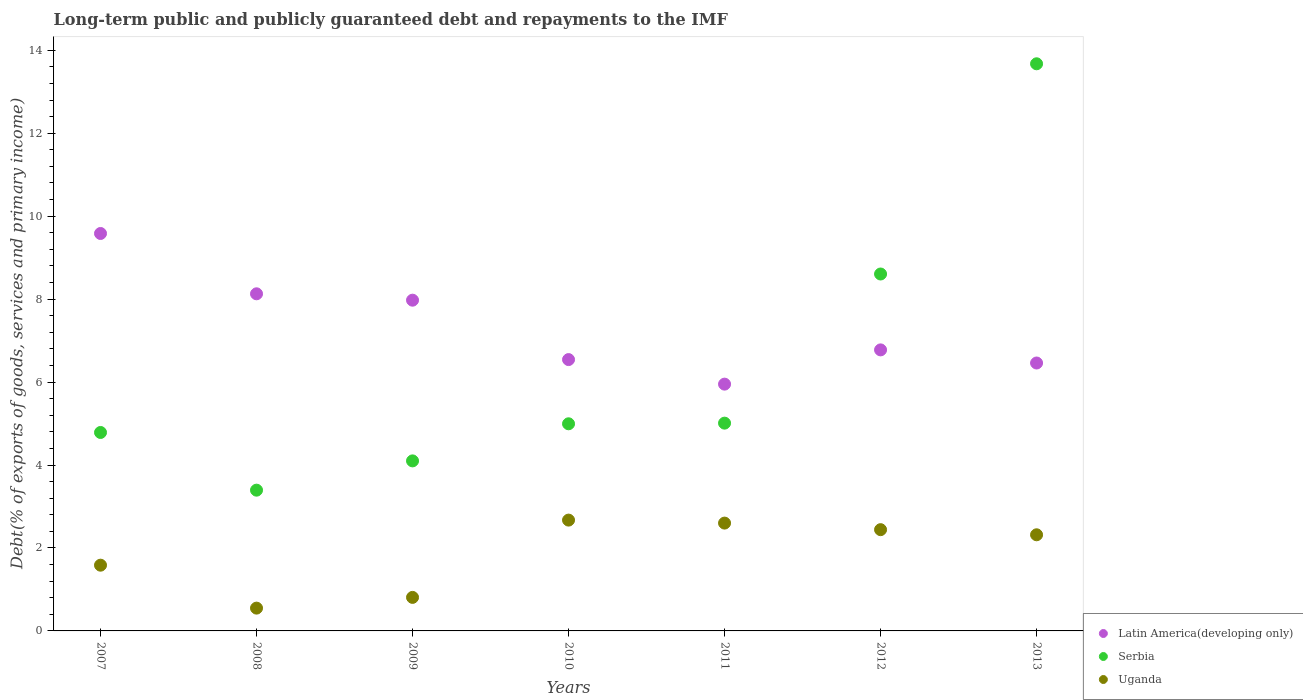How many different coloured dotlines are there?
Ensure brevity in your answer.  3. What is the debt and repayments in Latin America(developing only) in 2012?
Provide a succinct answer. 6.78. Across all years, what is the maximum debt and repayments in Serbia?
Offer a very short reply. 13.67. Across all years, what is the minimum debt and repayments in Serbia?
Make the answer very short. 3.39. What is the total debt and repayments in Serbia in the graph?
Make the answer very short. 44.56. What is the difference between the debt and repayments in Latin America(developing only) in 2010 and that in 2012?
Your answer should be very brief. -0.23. What is the difference between the debt and repayments in Uganda in 2012 and the debt and repayments in Serbia in 2008?
Ensure brevity in your answer.  -0.95. What is the average debt and repayments in Uganda per year?
Provide a short and direct response. 1.85. In the year 2008, what is the difference between the debt and repayments in Serbia and debt and repayments in Latin America(developing only)?
Your answer should be compact. -4.73. What is the ratio of the debt and repayments in Serbia in 2008 to that in 2013?
Provide a short and direct response. 0.25. What is the difference between the highest and the second highest debt and repayments in Serbia?
Your answer should be compact. 5.07. What is the difference between the highest and the lowest debt and repayments in Uganda?
Make the answer very short. 2.12. Is it the case that in every year, the sum of the debt and repayments in Serbia and debt and repayments in Latin America(developing only)  is greater than the debt and repayments in Uganda?
Offer a very short reply. Yes. How many dotlines are there?
Offer a very short reply. 3. How are the legend labels stacked?
Offer a terse response. Vertical. What is the title of the graph?
Keep it short and to the point. Long-term public and publicly guaranteed debt and repayments to the IMF. Does "Kiribati" appear as one of the legend labels in the graph?
Provide a succinct answer. No. What is the label or title of the Y-axis?
Provide a short and direct response. Debt(% of exports of goods, services and primary income). What is the Debt(% of exports of goods, services and primary income) in Latin America(developing only) in 2007?
Give a very brief answer. 9.58. What is the Debt(% of exports of goods, services and primary income) in Serbia in 2007?
Offer a very short reply. 4.78. What is the Debt(% of exports of goods, services and primary income) in Uganda in 2007?
Your answer should be very brief. 1.58. What is the Debt(% of exports of goods, services and primary income) in Latin America(developing only) in 2008?
Offer a very short reply. 8.13. What is the Debt(% of exports of goods, services and primary income) of Serbia in 2008?
Make the answer very short. 3.39. What is the Debt(% of exports of goods, services and primary income) of Uganda in 2008?
Offer a terse response. 0.55. What is the Debt(% of exports of goods, services and primary income) of Latin America(developing only) in 2009?
Make the answer very short. 7.97. What is the Debt(% of exports of goods, services and primary income) of Serbia in 2009?
Your response must be concise. 4.1. What is the Debt(% of exports of goods, services and primary income) in Uganda in 2009?
Provide a succinct answer. 0.81. What is the Debt(% of exports of goods, services and primary income) in Latin America(developing only) in 2010?
Offer a very short reply. 6.54. What is the Debt(% of exports of goods, services and primary income) of Serbia in 2010?
Keep it short and to the point. 4.99. What is the Debt(% of exports of goods, services and primary income) of Uganda in 2010?
Give a very brief answer. 2.67. What is the Debt(% of exports of goods, services and primary income) of Latin America(developing only) in 2011?
Offer a very short reply. 5.95. What is the Debt(% of exports of goods, services and primary income) of Serbia in 2011?
Provide a succinct answer. 5.01. What is the Debt(% of exports of goods, services and primary income) in Uganda in 2011?
Give a very brief answer. 2.6. What is the Debt(% of exports of goods, services and primary income) in Latin America(developing only) in 2012?
Make the answer very short. 6.78. What is the Debt(% of exports of goods, services and primary income) of Serbia in 2012?
Your answer should be compact. 8.6. What is the Debt(% of exports of goods, services and primary income) of Uganda in 2012?
Offer a terse response. 2.44. What is the Debt(% of exports of goods, services and primary income) of Latin America(developing only) in 2013?
Your answer should be very brief. 6.46. What is the Debt(% of exports of goods, services and primary income) of Serbia in 2013?
Your answer should be compact. 13.67. What is the Debt(% of exports of goods, services and primary income) in Uganda in 2013?
Your answer should be compact. 2.32. Across all years, what is the maximum Debt(% of exports of goods, services and primary income) of Latin America(developing only)?
Provide a succinct answer. 9.58. Across all years, what is the maximum Debt(% of exports of goods, services and primary income) of Serbia?
Your response must be concise. 13.67. Across all years, what is the maximum Debt(% of exports of goods, services and primary income) of Uganda?
Make the answer very short. 2.67. Across all years, what is the minimum Debt(% of exports of goods, services and primary income) of Latin America(developing only)?
Your answer should be compact. 5.95. Across all years, what is the minimum Debt(% of exports of goods, services and primary income) of Serbia?
Ensure brevity in your answer.  3.39. Across all years, what is the minimum Debt(% of exports of goods, services and primary income) of Uganda?
Your answer should be very brief. 0.55. What is the total Debt(% of exports of goods, services and primary income) in Latin America(developing only) in the graph?
Make the answer very short. 51.41. What is the total Debt(% of exports of goods, services and primary income) in Serbia in the graph?
Your answer should be very brief. 44.56. What is the total Debt(% of exports of goods, services and primary income) of Uganda in the graph?
Your answer should be compact. 12.97. What is the difference between the Debt(% of exports of goods, services and primary income) in Latin America(developing only) in 2007 and that in 2008?
Your answer should be compact. 1.45. What is the difference between the Debt(% of exports of goods, services and primary income) of Serbia in 2007 and that in 2008?
Offer a terse response. 1.39. What is the difference between the Debt(% of exports of goods, services and primary income) in Uganda in 2007 and that in 2008?
Give a very brief answer. 1.04. What is the difference between the Debt(% of exports of goods, services and primary income) in Latin America(developing only) in 2007 and that in 2009?
Make the answer very short. 1.61. What is the difference between the Debt(% of exports of goods, services and primary income) of Serbia in 2007 and that in 2009?
Keep it short and to the point. 0.69. What is the difference between the Debt(% of exports of goods, services and primary income) in Uganda in 2007 and that in 2009?
Your response must be concise. 0.78. What is the difference between the Debt(% of exports of goods, services and primary income) of Latin America(developing only) in 2007 and that in 2010?
Make the answer very short. 3.04. What is the difference between the Debt(% of exports of goods, services and primary income) of Serbia in 2007 and that in 2010?
Provide a short and direct response. -0.21. What is the difference between the Debt(% of exports of goods, services and primary income) of Uganda in 2007 and that in 2010?
Offer a terse response. -1.09. What is the difference between the Debt(% of exports of goods, services and primary income) in Latin America(developing only) in 2007 and that in 2011?
Provide a succinct answer. 3.63. What is the difference between the Debt(% of exports of goods, services and primary income) in Serbia in 2007 and that in 2011?
Make the answer very short. -0.23. What is the difference between the Debt(% of exports of goods, services and primary income) of Uganda in 2007 and that in 2011?
Offer a very short reply. -1.01. What is the difference between the Debt(% of exports of goods, services and primary income) in Latin America(developing only) in 2007 and that in 2012?
Give a very brief answer. 2.81. What is the difference between the Debt(% of exports of goods, services and primary income) of Serbia in 2007 and that in 2012?
Your response must be concise. -3.82. What is the difference between the Debt(% of exports of goods, services and primary income) in Uganda in 2007 and that in 2012?
Offer a terse response. -0.86. What is the difference between the Debt(% of exports of goods, services and primary income) of Latin America(developing only) in 2007 and that in 2013?
Give a very brief answer. 3.12. What is the difference between the Debt(% of exports of goods, services and primary income) in Serbia in 2007 and that in 2013?
Offer a terse response. -8.89. What is the difference between the Debt(% of exports of goods, services and primary income) in Uganda in 2007 and that in 2013?
Keep it short and to the point. -0.73. What is the difference between the Debt(% of exports of goods, services and primary income) of Latin America(developing only) in 2008 and that in 2009?
Offer a terse response. 0.15. What is the difference between the Debt(% of exports of goods, services and primary income) in Serbia in 2008 and that in 2009?
Your response must be concise. -0.71. What is the difference between the Debt(% of exports of goods, services and primary income) of Uganda in 2008 and that in 2009?
Ensure brevity in your answer.  -0.26. What is the difference between the Debt(% of exports of goods, services and primary income) in Latin America(developing only) in 2008 and that in 2010?
Ensure brevity in your answer.  1.59. What is the difference between the Debt(% of exports of goods, services and primary income) in Serbia in 2008 and that in 2010?
Offer a very short reply. -1.6. What is the difference between the Debt(% of exports of goods, services and primary income) of Uganda in 2008 and that in 2010?
Keep it short and to the point. -2.12. What is the difference between the Debt(% of exports of goods, services and primary income) of Latin America(developing only) in 2008 and that in 2011?
Provide a succinct answer. 2.18. What is the difference between the Debt(% of exports of goods, services and primary income) of Serbia in 2008 and that in 2011?
Provide a short and direct response. -1.62. What is the difference between the Debt(% of exports of goods, services and primary income) of Uganda in 2008 and that in 2011?
Provide a short and direct response. -2.05. What is the difference between the Debt(% of exports of goods, services and primary income) in Latin America(developing only) in 2008 and that in 2012?
Your response must be concise. 1.35. What is the difference between the Debt(% of exports of goods, services and primary income) in Serbia in 2008 and that in 2012?
Offer a terse response. -5.21. What is the difference between the Debt(% of exports of goods, services and primary income) in Uganda in 2008 and that in 2012?
Your answer should be very brief. -1.89. What is the difference between the Debt(% of exports of goods, services and primary income) of Latin America(developing only) in 2008 and that in 2013?
Give a very brief answer. 1.67. What is the difference between the Debt(% of exports of goods, services and primary income) of Serbia in 2008 and that in 2013?
Provide a short and direct response. -10.28. What is the difference between the Debt(% of exports of goods, services and primary income) of Uganda in 2008 and that in 2013?
Make the answer very short. -1.77. What is the difference between the Debt(% of exports of goods, services and primary income) in Latin America(developing only) in 2009 and that in 2010?
Give a very brief answer. 1.43. What is the difference between the Debt(% of exports of goods, services and primary income) in Serbia in 2009 and that in 2010?
Give a very brief answer. -0.89. What is the difference between the Debt(% of exports of goods, services and primary income) in Uganda in 2009 and that in 2010?
Offer a terse response. -1.86. What is the difference between the Debt(% of exports of goods, services and primary income) of Latin America(developing only) in 2009 and that in 2011?
Offer a very short reply. 2.02. What is the difference between the Debt(% of exports of goods, services and primary income) in Serbia in 2009 and that in 2011?
Your response must be concise. -0.91. What is the difference between the Debt(% of exports of goods, services and primary income) of Uganda in 2009 and that in 2011?
Your answer should be compact. -1.79. What is the difference between the Debt(% of exports of goods, services and primary income) of Latin America(developing only) in 2009 and that in 2012?
Provide a short and direct response. 1.2. What is the difference between the Debt(% of exports of goods, services and primary income) of Serbia in 2009 and that in 2012?
Offer a very short reply. -4.51. What is the difference between the Debt(% of exports of goods, services and primary income) in Uganda in 2009 and that in 2012?
Ensure brevity in your answer.  -1.63. What is the difference between the Debt(% of exports of goods, services and primary income) in Latin America(developing only) in 2009 and that in 2013?
Give a very brief answer. 1.51. What is the difference between the Debt(% of exports of goods, services and primary income) of Serbia in 2009 and that in 2013?
Give a very brief answer. -9.57. What is the difference between the Debt(% of exports of goods, services and primary income) in Uganda in 2009 and that in 2013?
Your answer should be compact. -1.51. What is the difference between the Debt(% of exports of goods, services and primary income) of Latin America(developing only) in 2010 and that in 2011?
Provide a succinct answer. 0.59. What is the difference between the Debt(% of exports of goods, services and primary income) of Serbia in 2010 and that in 2011?
Make the answer very short. -0.02. What is the difference between the Debt(% of exports of goods, services and primary income) in Uganda in 2010 and that in 2011?
Keep it short and to the point. 0.07. What is the difference between the Debt(% of exports of goods, services and primary income) of Latin America(developing only) in 2010 and that in 2012?
Offer a very short reply. -0.23. What is the difference between the Debt(% of exports of goods, services and primary income) in Serbia in 2010 and that in 2012?
Keep it short and to the point. -3.61. What is the difference between the Debt(% of exports of goods, services and primary income) in Uganda in 2010 and that in 2012?
Offer a terse response. 0.23. What is the difference between the Debt(% of exports of goods, services and primary income) of Latin America(developing only) in 2010 and that in 2013?
Provide a short and direct response. 0.08. What is the difference between the Debt(% of exports of goods, services and primary income) in Serbia in 2010 and that in 2013?
Your answer should be compact. -8.68. What is the difference between the Debt(% of exports of goods, services and primary income) of Uganda in 2010 and that in 2013?
Give a very brief answer. 0.35. What is the difference between the Debt(% of exports of goods, services and primary income) of Latin America(developing only) in 2011 and that in 2012?
Offer a very short reply. -0.83. What is the difference between the Debt(% of exports of goods, services and primary income) of Serbia in 2011 and that in 2012?
Your answer should be very brief. -3.6. What is the difference between the Debt(% of exports of goods, services and primary income) in Uganda in 2011 and that in 2012?
Your answer should be compact. 0.16. What is the difference between the Debt(% of exports of goods, services and primary income) in Latin America(developing only) in 2011 and that in 2013?
Offer a very short reply. -0.51. What is the difference between the Debt(% of exports of goods, services and primary income) of Serbia in 2011 and that in 2013?
Provide a succinct answer. -8.66. What is the difference between the Debt(% of exports of goods, services and primary income) of Uganda in 2011 and that in 2013?
Offer a terse response. 0.28. What is the difference between the Debt(% of exports of goods, services and primary income) in Latin America(developing only) in 2012 and that in 2013?
Offer a very short reply. 0.32. What is the difference between the Debt(% of exports of goods, services and primary income) in Serbia in 2012 and that in 2013?
Ensure brevity in your answer.  -5.07. What is the difference between the Debt(% of exports of goods, services and primary income) of Uganda in 2012 and that in 2013?
Provide a succinct answer. 0.12. What is the difference between the Debt(% of exports of goods, services and primary income) of Latin America(developing only) in 2007 and the Debt(% of exports of goods, services and primary income) of Serbia in 2008?
Keep it short and to the point. 6.19. What is the difference between the Debt(% of exports of goods, services and primary income) in Latin America(developing only) in 2007 and the Debt(% of exports of goods, services and primary income) in Uganda in 2008?
Ensure brevity in your answer.  9.03. What is the difference between the Debt(% of exports of goods, services and primary income) in Serbia in 2007 and the Debt(% of exports of goods, services and primary income) in Uganda in 2008?
Provide a short and direct response. 4.23. What is the difference between the Debt(% of exports of goods, services and primary income) of Latin America(developing only) in 2007 and the Debt(% of exports of goods, services and primary income) of Serbia in 2009?
Provide a succinct answer. 5.48. What is the difference between the Debt(% of exports of goods, services and primary income) in Latin America(developing only) in 2007 and the Debt(% of exports of goods, services and primary income) in Uganda in 2009?
Provide a short and direct response. 8.77. What is the difference between the Debt(% of exports of goods, services and primary income) in Serbia in 2007 and the Debt(% of exports of goods, services and primary income) in Uganda in 2009?
Provide a succinct answer. 3.98. What is the difference between the Debt(% of exports of goods, services and primary income) of Latin America(developing only) in 2007 and the Debt(% of exports of goods, services and primary income) of Serbia in 2010?
Provide a succinct answer. 4.59. What is the difference between the Debt(% of exports of goods, services and primary income) of Latin America(developing only) in 2007 and the Debt(% of exports of goods, services and primary income) of Uganda in 2010?
Provide a succinct answer. 6.91. What is the difference between the Debt(% of exports of goods, services and primary income) in Serbia in 2007 and the Debt(% of exports of goods, services and primary income) in Uganda in 2010?
Offer a terse response. 2.11. What is the difference between the Debt(% of exports of goods, services and primary income) of Latin America(developing only) in 2007 and the Debt(% of exports of goods, services and primary income) of Serbia in 2011?
Offer a terse response. 4.57. What is the difference between the Debt(% of exports of goods, services and primary income) of Latin America(developing only) in 2007 and the Debt(% of exports of goods, services and primary income) of Uganda in 2011?
Your response must be concise. 6.98. What is the difference between the Debt(% of exports of goods, services and primary income) in Serbia in 2007 and the Debt(% of exports of goods, services and primary income) in Uganda in 2011?
Ensure brevity in your answer.  2.18. What is the difference between the Debt(% of exports of goods, services and primary income) in Latin America(developing only) in 2007 and the Debt(% of exports of goods, services and primary income) in Serbia in 2012?
Give a very brief answer. 0.98. What is the difference between the Debt(% of exports of goods, services and primary income) of Latin America(developing only) in 2007 and the Debt(% of exports of goods, services and primary income) of Uganda in 2012?
Keep it short and to the point. 7.14. What is the difference between the Debt(% of exports of goods, services and primary income) of Serbia in 2007 and the Debt(% of exports of goods, services and primary income) of Uganda in 2012?
Your answer should be very brief. 2.34. What is the difference between the Debt(% of exports of goods, services and primary income) in Latin America(developing only) in 2007 and the Debt(% of exports of goods, services and primary income) in Serbia in 2013?
Provide a succinct answer. -4.09. What is the difference between the Debt(% of exports of goods, services and primary income) of Latin America(developing only) in 2007 and the Debt(% of exports of goods, services and primary income) of Uganda in 2013?
Offer a very short reply. 7.26. What is the difference between the Debt(% of exports of goods, services and primary income) of Serbia in 2007 and the Debt(% of exports of goods, services and primary income) of Uganda in 2013?
Offer a very short reply. 2.47. What is the difference between the Debt(% of exports of goods, services and primary income) in Latin America(developing only) in 2008 and the Debt(% of exports of goods, services and primary income) in Serbia in 2009?
Provide a short and direct response. 4.03. What is the difference between the Debt(% of exports of goods, services and primary income) in Latin America(developing only) in 2008 and the Debt(% of exports of goods, services and primary income) in Uganda in 2009?
Keep it short and to the point. 7.32. What is the difference between the Debt(% of exports of goods, services and primary income) in Serbia in 2008 and the Debt(% of exports of goods, services and primary income) in Uganda in 2009?
Offer a terse response. 2.59. What is the difference between the Debt(% of exports of goods, services and primary income) of Latin America(developing only) in 2008 and the Debt(% of exports of goods, services and primary income) of Serbia in 2010?
Make the answer very short. 3.13. What is the difference between the Debt(% of exports of goods, services and primary income) of Latin America(developing only) in 2008 and the Debt(% of exports of goods, services and primary income) of Uganda in 2010?
Your answer should be very brief. 5.46. What is the difference between the Debt(% of exports of goods, services and primary income) in Serbia in 2008 and the Debt(% of exports of goods, services and primary income) in Uganda in 2010?
Provide a succinct answer. 0.72. What is the difference between the Debt(% of exports of goods, services and primary income) of Latin America(developing only) in 2008 and the Debt(% of exports of goods, services and primary income) of Serbia in 2011?
Offer a very short reply. 3.12. What is the difference between the Debt(% of exports of goods, services and primary income) of Latin America(developing only) in 2008 and the Debt(% of exports of goods, services and primary income) of Uganda in 2011?
Your answer should be very brief. 5.53. What is the difference between the Debt(% of exports of goods, services and primary income) of Serbia in 2008 and the Debt(% of exports of goods, services and primary income) of Uganda in 2011?
Your answer should be very brief. 0.79. What is the difference between the Debt(% of exports of goods, services and primary income) in Latin America(developing only) in 2008 and the Debt(% of exports of goods, services and primary income) in Serbia in 2012?
Make the answer very short. -0.48. What is the difference between the Debt(% of exports of goods, services and primary income) in Latin America(developing only) in 2008 and the Debt(% of exports of goods, services and primary income) in Uganda in 2012?
Make the answer very short. 5.69. What is the difference between the Debt(% of exports of goods, services and primary income) of Serbia in 2008 and the Debt(% of exports of goods, services and primary income) of Uganda in 2012?
Provide a succinct answer. 0.95. What is the difference between the Debt(% of exports of goods, services and primary income) in Latin America(developing only) in 2008 and the Debt(% of exports of goods, services and primary income) in Serbia in 2013?
Offer a very short reply. -5.55. What is the difference between the Debt(% of exports of goods, services and primary income) in Latin America(developing only) in 2008 and the Debt(% of exports of goods, services and primary income) in Uganda in 2013?
Offer a terse response. 5.81. What is the difference between the Debt(% of exports of goods, services and primary income) in Serbia in 2008 and the Debt(% of exports of goods, services and primary income) in Uganda in 2013?
Give a very brief answer. 1.08. What is the difference between the Debt(% of exports of goods, services and primary income) of Latin America(developing only) in 2009 and the Debt(% of exports of goods, services and primary income) of Serbia in 2010?
Your answer should be very brief. 2.98. What is the difference between the Debt(% of exports of goods, services and primary income) of Latin America(developing only) in 2009 and the Debt(% of exports of goods, services and primary income) of Uganda in 2010?
Offer a terse response. 5.3. What is the difference between the Debt(% of exports of goods, services and primary income) in Serbia in 2009 and the Debt(% of exports of goods, services and primary income) in Uganda in 2010?
Make the answer very short. 1.43. What is the difference between the Debt(% of exports of goods, services and primary income) of Latin America(developing only) in 2009 and the Debt(% of exports of goods, services and primary income) of Serbia in 2011?
Your answer should be very brief. 2.96. What is the difference between the Debt(% of exports of goods, services and primary income) of Latin America(developing only) in 2009 and the Debt(% of exports of goods, services and primary income) of Uganda in 2011?
Provide a succinct answer. 5.37. What is the difference between the Debt(% of exports of goods, services and primary income) in Serbia in 2009 and the Debt(% of exports of goods, services and primary income) in Uganda in 2011?
Make the answer very short. 1.5. What is the difference between the Debt(% of exports of goods, services and primary income) of Latin America(developing only) in 2009 and the Debt(% of exports of goods, services and primary income) of Serbia in 2012?
Your response must be concise. -0.63. What is the difference between the Debt(% of exports of goods, services and primary income) of Latin America(developing only) in 2009 and the Debt(% of exports of goods, services and primary income) of Uganda in 2012?
Your answer should be very brief. 5.53. What is the difference between the Debt(% of exports of goods, services and primary income) of Serbia in 2009 and the Debt(% of exports of goods, services and primary income) of Uganda in 2012?
Your answer should be very brief. 1.66. What is the difference between the Debt(% of exports of goods, services and primary income) in Latin America(developing only) in 2009 and the Debt(% of exports of goods, services and primary income) in Serbia in 2013?
Make the answer very short. -5.7. What is the difference between the Debt(% of exports of goods, services and primary income) in Latin America(developing only) in 2009 and the Debt(% of exports of goods, services and primary income) in Uganda in 2013?
Your answer should be very brief. 5.66. What is the difference between the Debt(% of exports of goods, services and primary income) in Serbia in 2009 and the Debt(% of exports of goods, services and primary income) in Uganda in 2013?
Provide a short and direct response. 1.78. What is the difference between the Debt(% of exports of goods, services and primary income) of Latin America(developing only) in 2010 and the Debt(% of exports of goods, services and primary income) of Serbia in 2011?
Offer a very short reply. 1.53. What is the difference between the Debt(% of exports of goods, services and primary income) in Latin America(developing only) in 2010 and the Debt(% of exports of goods, services and primary income) in Uganda in 2011?
Provide a short and direct response. 3.94. What is the difference between the Debt(% of exports of goods, services and primary income) of Serbia in 2010 and the Debt(% of exports of goods, services and primary income) of Uganda in 2011?
Offer a terse response. 2.39. What is the difference between the Debt(% of exports of goods, services and primary income) of Latin America(developing only) in 2010 and the Debt(% of exports of goods, services and primary income) of Serbia in 2012?
Your answer should be compact. -2.06. What is the difference between the Debt(% of exports of goods, services and primary income) of Latin America(developing only) in 2010 and the Debt(% of exports of goods, services and primary income) of Uganda in 2012?
Offer a terse response. 4.1. What is the difference between the Debt(% of exports of goods, services and primary income) of Serbia in 2010 and the Debt(% of exports of goods, services and primary income) of Uganda in 2012?
Keep it short and to the point. 2.55. What is the difference between the Debt(% of exports of goods, services and primary income) in Latin America(developing only) in 2010 and the Debt(% of exports of goods, services and primary income) in Serbia in 2013?
Your response must be concise. -7.13. What is the difference between the Debt(% of exports of goods, services and primary income) of Latin America(developing only) in 2010 and the Debt(% of exports of goods, services and primary income) of Uganda in 2013?
Offer a very short reply. 4.22. What is the difference between the Debt(% of exports of goods, services and primary income) of Serbia in 2010 and the Debt(% of exports of goods, services and primary income) of Uganda in 2013?
Offer a terse response. 2.68. What is the difference between the Debt(% of exports of goods, services and primary income) in Latin America(developing only) in 2011 and the Debt(% of exports of goods, services and primary income) in Serbia in 2012?
Provide a short and direct response. -2.66. What is the difference between the Debt(% of exports of goods, services and primary income) of Latin America(developing only) in 2011 and the Debt(% of exports of goods, services and primary income) of Uganda in 2012?
Your response must be concise. 3.51. What is the difference between the Debt(% of exports of goods, services and primary income) in Serbia in 2011 and the Debt(% of exports of goods, services and primary income) in Uganda in 2012?
Ensure brevity in your answer.  2.57. What is the difference between the Debt(% of exports of goods, services and primary income) in Latin America(developing only) in 2011 and the Debt(% of exports of goods, services and primary income) in Serbia in 2013?
Provide a short and direct response. -7.72. What is the difference between the Debt(% of exports of goods, services and primary income) of Latin America(developing only) in 2011 and the Debt(% of exports of goods, services and primary income) of Uganda in 2013?
Your answer should be very brief. 3.63. What is the difference between the Debt(% of exports of goods, services and primary income) of Serbia in 2011 and the Debt(% of exports of goods, services and primary income) of Uganda in 2013?
Give a very brief answer. 2.69. What is the difference between the Debt(% of exports of goods, services and primary income) of Latin America(developing only) in 2012 and the Debt(% of exports of goods, services and primary income) of Serbia in 2013?
Offer a terse response. -6.9. What is the difference between the Debt(% of exports of goods, services and primary income) in Latin America(developing only) in 2012 and the Debt(% of exports of goods, services and primary income) in Uganda in 2013?
Offer a terse response. 4.46. What is the difference between the Debt(% of exports of goods, services and primary income) in Serbia in 2012 and the Debt(% of exports of goods, services and primary income) in Uganda in 2013?
Make the answer very short. 6.29. What is the average Debt(% of exports of goods, services and primary income) of Latin America(developing only) per year?
Offer a very short reply. 7.34. What is the average Debt(% of exports of goods, services and primary income) of Serbia per year?
Your answer should be compact. 6.37. What is the average Debt(% of exports of goods, services and primary income) of Uganda per year?
Your answer should be very brief. 1.85. In the year 2007, what is the difference between the Debt(% of exports of goods, services and primary income) of Latin America(developing only) and Debt(% of exports of goods, services and primary income) of Serbia?
Provide a short and direct response. 4.8. In the year 2007, what is the difference between the Debt(% of exports of goods, services and primary income) of Latin America(developing only) and Debt(% of exports of goods, services and primary income) of Uganda?
Your response must be concise. 8. In the year 2007, what is the difference between the Debt(% of exports of goods, services and primary income) of Serbia and Debt(% of exports of goods, services and primary income) of Uganda?
Offer a terse response. 3.2. In the year 2008, what is the difference between the Debt(% of exports of goods, services and primary income) of Latin America(developing only) and Debt(% of exports of goods, services and primary income) of Serbia?
Your answer should be compact. 4.73. In the year 2008, what is the difference between the Debt(% of exports of goods, services and primary income) in Latin America(developing only) and Debt(% of exports of goods, services and primary income) in Uganda?
Your answer should be compact. 7.58. In the year 2008, what is the difference between the Debt(% of exports of goods, services and primary income) of Serbia and Debt(% of exports of goods, services and primary income) of Uganda?
Keep it short and to the point. 2.84. In the year 2009, what is the difference between the Debt(% of exports of goods, services and primary income) of Latin America(developing only) and Debt(% of exports of goods, services and primary income) of Serbia?
Make the answer very short. 3.87. In the year 2009, what is the difference between the Debt(% of exports of goods, services and primary income) in Latin America(developing only) and Debt(% of exports of goods, services and primary income) in Uganda?
Ensure brevity in your answer.  7.17. In the year 2009, what is the difference between the Debt(% of exports of goods, services and primary income) of Serbia and Debt(% of exports of goods, services and primary income) of Uganda?
Keep it short and to the point. 3.29. In the year 2010, what is the difference between the Debt(% of exports of goods, services and primary income) in Latin America(developing only) and Debt(% of exports of goods, services and primary income) in Serbia?
Your answer should be compact. 1.55. In the year 2010, what is the difference between the Debt(% of exports of goods, services and primary income) of Latin America(developing only) and Debt(% of exports of goods, services and primary income) of Uganda?
Offer a terse response. 3.87. In the year 2010, what is the difference between the Debt(% of exports of goods, services and primary income) of Serbia and Debt(% of exports of goods, services and primary income) of Uganda?
Keep it short and to the point. 2.32. In the year 2011, what is the difference between the Debt(% of exports of goods, services and primary income) in Latin America(developing only) and Debt(% of exports of goods, services and primary income) in Serbia?
Offer a terse response. 0.94. In the year 2011, what is the difference between the Debt(% of exports of goods, services and primary income) in Latin America(developing only) and Debt(% of exports of goods, services and primary income) in Uganda?
Offer a terse response. 3.35. In the year 2011, what is the difference between the Debt(% of exports of goods, services and primary income) of Serbia and Debt(% of exports of goods, services and primary income) of Uganda?
Provide a short and direct response. 2.41. In the year 2012, what is the difference between the Debt(% of exports of goods, services and primary income) of Latin America(developing only) and Debt(% of exports of goods, services and primary income) of Serbia?
Keep it short and to the point. -1.83. In the year 2012, what is the difference between the Debt(% of exports of goods, services and primary income) in Latin America(developing only) and Debt(% of exports of goods, services and primary income) in Uganda?
Your answer should be compact. 4.33. In the year 2012, what is the difference between the Debt(% of exports of goods, services and primary income) of Serbia and Debt(% of exports of goods, services and primary income) of Uganda?
Ensure brevity in your answer.  6.16. In the year 2013, what is the difference between the Debt(% of exports of goods, services and primary income) of Latin America(developing only) and Debt(% of exports of goods, services and primary income) of Serbia?
Provide a succinct answer. -7.21. In the year 2013, what is the difference between the Debt(% of exports of goods, services and primary income) in Latin America(developing only) and Debt(% of exports of goods, services and primary income) in Uganda?
Offer a very short reply. 4.14. In the year 2013, what is the difference between the Debt(% of exports of goods, services and primary income) of Serbia and Debt(% of exports of goods, services and primary income) of Uganda?
Offer a terse response. 11.36. What is the ratio of the Debt(% of exports of goods, services and primary income) of Latin America(developing only) in 2007 to that in 2008?
Give a very brief answer. 1.18. What is the ratio of the Debt(% of exports of goods, services and primary income) of Serbia in 2007 to that in 2008?
Keep it short and to the point. 1.41. What is the ratio of the Debt(% of exports of goods, services and primary income) of Uganda in 2007 to that in 2008?
Your answer should be very brief. 2.88. What is the ratio of the Debt(% of exports of goods, services and primary income) in Latin America(developing only) in 2007 to that in 2009?
Offer a terse response. 1.2. What is the ratio of the Debt(% of exports of goods, services and primary income) of Serbia in 2007 to that in 2009?
Offer a very short reply. 1.17. What is the ratio of the Debt(% of exports of goods, services and primary income) of Uganda in 2007 to that in 2009?
Provide a succinct answer. 1.96. What is the ratio of the Debt(% of exports of goods, services and primary income) in Latin America(developing only) in 2007 to that in 2010?
Provide a short and direct response. 1.46. What is the ratio of the Debt(% of exports of goods, services and primary income) in Serbia in 2007 to that in 2010?
Make the answer very short. 0.96. What is the ratio of the Debt(% of exports of goods, services and primary income) in Uganda in 2007 to that in 2010?
Your answer should be compact. 0.59. What is the ratio of the Debt(% of exports of goods, services and primary income) in Latin America(developing only) in 2007 to that in 2011?
Your response must be concise. 1.61. What is the ratio of the Debt(% of exports of goods, services and primary income) of Serbia in 2007 to that in 2011?
Your answer should be very brief. 0.96. What is the ratio of the Debt(% of exports of goods, services and primary income) in Uganda in 2007 to that in 2011?
Your answer should be very brief. 0.61. What is the ratio of the Debt(% of exports of goods, services and primary income) of Latin America(developing only) in 2007 to that in 2012?
Give a very brief answer. 1.41. What is the ratio of the Debt(% of exports of goods, services and primary income) in Serbia in 2007 to that in 2012?
Offer a very short reply. 0.56. What is the ratio of the Debt(% of exports of goods, services and primary income) in Uganda in 2007 to that in 2012?
Ensure brevity in your answer.  0.65. What is the ratio of the Debt(% of exports of goods, services and primary income) of Latin America(developing only) in 2007 to that in 2013?
Your answer should be very brief. 1.48. What is the ratio of the Debt(% of exports of goods, services and primary income) of Serbia in 2007 to that in 2013?
Your answer should be compact. 0.35. What is the ratio of the Debt(% of exports of goods, services and primary income) of Uganda in 2007 to that in 2013?
Give a very brief answer. 0.68. What is the ratio of the Debt(% of exports of goods, services and primary income) in Latin America(developing only) in 2008 to that in 2009?
Your answer should be very brief. 1.02. What is the ratio of the Debt(% of exports of goods, services and primary income) of Serbia in 2008 to that in 2009?
Keep it short and to the point. 0.83. What is the ratio of the Debt(% of exports of goods, services and primary income) of Uganda in 2008 to that in 2009?
Your response must be concise. 0.68. What is the ratio of the Debt(% of exports of goods, services and primary income) of Latin America(developing only) in 2008 to that in 2010?
Your answer should be very brief. 1.24. What is the ratio of the Debt(% of exports of goods, services and primary income) of Serbia in 2008 to that in 2010?
Provide a succinct answer. 0.68. What is the ratio of the Debt(% of exports of goods, services and primary income) of Uganda in 2008 to that in 2010?
Provide a succinct answer. 0.21. What is the ratio of the Debt(% of exports of goods, services and primary income) in Latin America(developing only) in 2008 to that in 2011?
Your response must be concise. 1.37. What is the ratio of the Debt(% of exports of goods, services and primary income) of Serbia in 2008 to that in 2011?
Offer a very short reply. 0.68. What is the ratio of the Debt(% of exports of goods, services and primary income) of Uganda in 2008 to that in 2011?
Ensure brevity in your answer.  0.21. What is the ratio of the Debt(% of exports of goods, services and primary income) in Latin America(developing only) in 2008 to that in 2012?
Offer a very short reply. 1.2. What is the ratio of the Debt(% of exports of goods, services and primary income) of Serbia in 2008 to that in 2012?
Your answer should be compact. 0.39. What is the ratio of the Debt(% of exports of goods, services and primary income) of Uganda in 2008 to that in 2012?
Keep it short and to the point. 0.23. What is the ratio of the Debt(% of exports of goods, services and primary income) of Latin America(developing only) in 2008 to that in 2013?
Offer a terse response. 1.26. What is the ratio of the Debt(% of exports of goods, services and primary income) of Serbia in 2008 to that in 2013?
Make the answer very short. 0.25. What is the ratio of the Debt(% of exports of goods, services and primary income) of Uganda in 2008 to that in 2013?
Offer a very short reply. 0.24. What is the ratio of the Debt(% of exports of goods, services and primary income) in Latin America(developing only) in 2009 to that in 2010?
Offer a very short reply. 1.22. What is the ratio of the Debt(% of exports of goods, services and primary income) in Serbia in 2009 to that in 2010?
Provide a succinct answer. 0.82. What is the ratio of the Debt(% of exports of goods, services and primary income) of Uganda in 2009 to that in 2010?
Offer a terse response. 0.3. What is the ratio of the Debt(% of exports of goods, services and primary income) of Latin America(developing only) in 2009 to that in 2011?
Your answer should be compact. 1.34. What is the ratio of the Debt(% of exports of goods, services and primary income) of Serbia in 2009 to that in 2011?
Your answer should be compact. 0.82. What is the ratio of the Debt(% of exports of goods, services and primary income) in Uganda in 2009 to that in 2011?
Provide a short and direct response. 0.31. What is the ratio of the Debt(% of exports of goods, services and primary income) of Latin America(developing only) in 2009 to that in 2012?
Your response must be concise. 1.18. What is the ratio of the Debt(% of exports of goods, services and primary income) in Serbia in 2009 to that in 2012?
Offer a very short reply. 0.48. What is the ratio of the Debt(% of exports of goods, services and primary income) in Uganda in 2009 to that in 2012?
Provide a short and direct response. 0.33. What is the ratio of the Debt(% of exports of goods, services and primary income) in Latin America(developing only) in 2009 to that in 2013?
Ensure brevity in your answer.  1.23. What is the ratio of the Debt(% of exports of goods, services and primary income) in Serbia in 2009 to that in 2013?
Give a very brief answer. 0.3. What is the ratio of the Debt(% of exports of goods, services and primary income) of Uganda in 2009 to that in 2013?
Your response must be concise. 0.35. What is the ratio of the Debt(% of exports of goods, services and primary income) of Latin America(developing only) in 2010 to that in 2011?
Provide a succinct answer. 1.1. What is the ratio of the Debt(% of exports of goods, services and primary income) of Serbia in 2010 to that in 2011?
Provide a short and direct response. 1. What is the ratio of the Debt(% of exports of goods, services and primary income) of Uganda in 2010 to that in 2011?
Keep it short and to the point. 1.03. What is the ratio of the Debt(% of exports of goods, services and primary income) of Latin America(developing only) in 2010 to that in 2012?
Offer a very short reply. 0.97. What is the ratio of the Debt(% of exports of goods, services and primary income) of Serbia in 2010 to that in 2012?
Your response must be concise. 0.58. What is the ratio of the Debt(% of exports of goods, services and primary income) of Uganda in 2010 to that in 2012?
Your answer should be very brief. 1.09. What is the ratio of the Debt(% of exports of goods, services and primary income) of Latin America(developing only) in 2010 to that in 2013?
Provide a short and direct response. 1.01. What is the ratio of the Debt(% of exports of goods, services and primary income) in Serbia in 2010 to that in 2013?
Offer a terse response. 0.37. What is the ratio of the Debt(% of exports of goods, services and primary income) of Uganda in 2010 to that in 2013?
Keep it short and to the point. 1.15. What is the ratio of the Debt(% of exports of goods, services and primary income) in Latin America(developing only) in 2011 to that in 2012?
Keep it short and to the point. 0.88. What is the ratio of the Debt(% of exports of goods, services and primary income) in Serbia in 2011 to that in 2012?
Give a very brief answer. 0.58. What is the ratio of the Debt(% of exports of goods, services and primary income) in Uganda in 2011 to that in 2012?
Provide a succinct answer. 1.06. What is the ratio of the Debt(% of exports of goods, services and primary income) of Latin America(developing only) in 2011 to that in 2013?
Your answer should be very brief. 0.92. What is the ratio of the Debt(% of exports of goods, services and primary income) in Serbia in 2011 to that in 2013?
Ensure brevity in your answer.  0.37. What is the ratio of the Debt(% of exports of goods, services and primary income) in Uganda in 2011 to that in 2013?
Your response must be concise. 1.12. What is the ratio of the Debt(% of exports of goods, services and primary income) in Latin America(developing only) in 2012 to that in 2013?
Keep it short and to the point. 1.05. What is the ratio of the Debt(% of exports of goods, services and primary income) in Serbia in 2012 to that in 2013?
Ensure brevity in your answer.  0.63. What is the ratio of the Debt(% of exports of goods, services and primary income) in Uganda in 2012 to that in 2013?
Give a very brief answer. 1.05. What is the difference between the highest and the second highest Debt(% of exports of goods, services and primary income) of Latin America(developing only)?
Your answer should be compact. 1.45. What is the difference between the highest and the second highest Debt(% of exports of goods, services and primary income) of Serbia?
Give a very brief answer. 5.07. What is the difference between the highest and the second highest Debt(% of exports of goods, services and primary income) in Uganda?
Offer a terse response. 0.07. What is the difference between the highest and the lowest Debt(% of exports of goods, services and primary income) of Latin America(developing only)?
Offer a terse response. 3.63. What is the difference between the highest and the lowest Debt(% of exports of goods, services and primary income) of Serbia?
Offer a terse response. 10.28. What is the difference between the highest and the lowest Debt(% of exports of goods, services and primary income) in Uganda?
Make the answer very short. 2.12. 